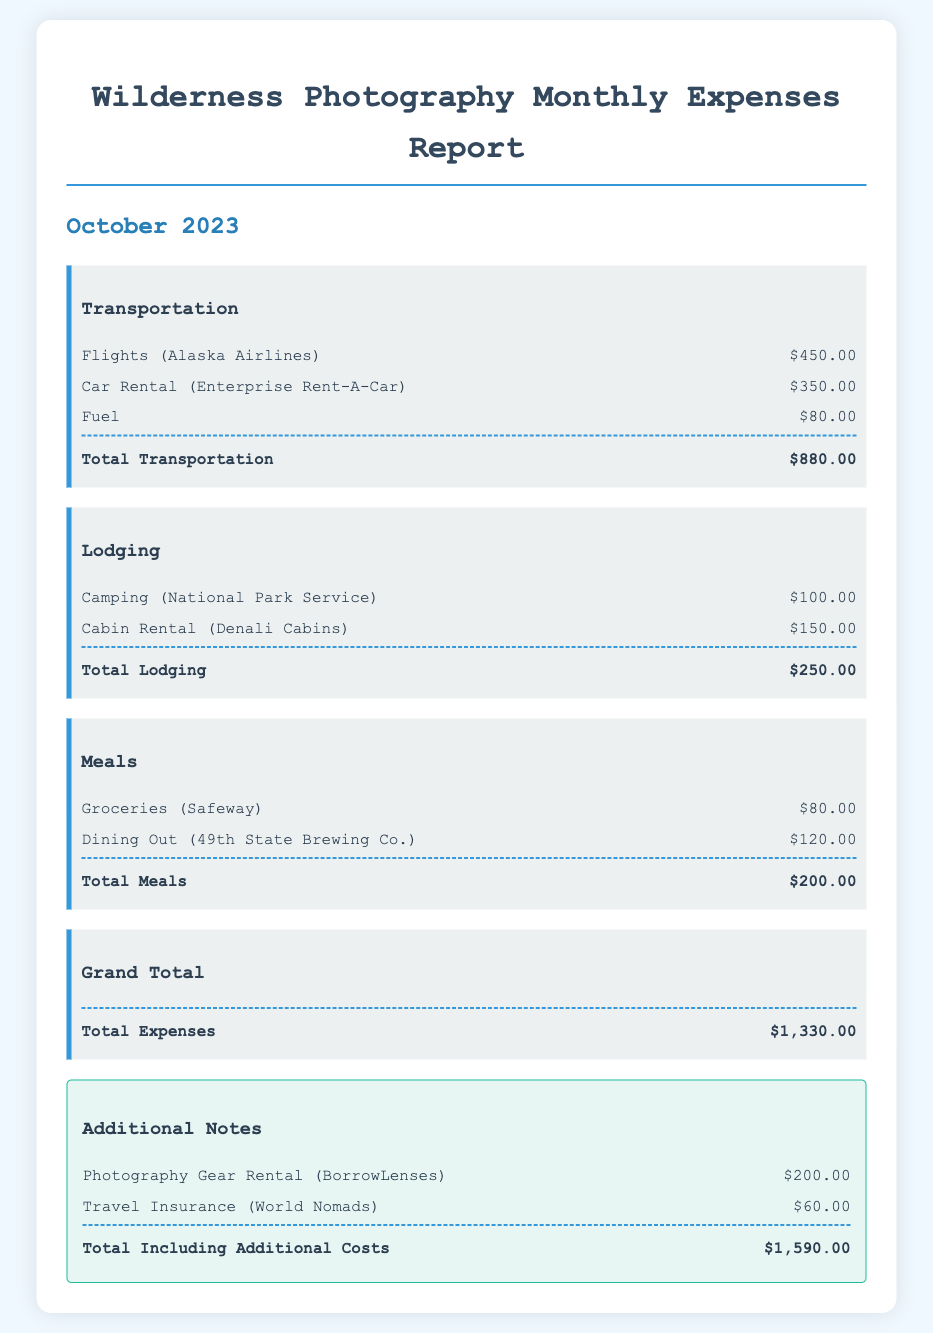What is the total transportation cost? The total for transportation is provided in the document as the sum of flights, car rental, and fuel costs, which is $450.00 + $350.00 + $80.00.
Answer: $880.00 How much was spent on lodging? The total lodging expense is the total of camping and cabin rental, which is $100.00 + $150.00.
Answer: $250.00 What was the cost of dining out? The document specifies that dining out at 49th State Brewing Co. occurred for $120.00.
Answer: $120.00 What is the grand total of expenses? The grand total is the overall sum of all expenses calculated in the report, which amounts to $1,330.00.
Answer: $1,330.00 How much was the photography gear rental? The photography gear rental cost is listed in the additional notes section as $200.00.
Answer: $200.00 What was the cost for travel insurance? The travel insurance cost from World Nomads is provided as $60.00 in the notes.
Answer: $60.00 What is the total including additional costs? The total including additional costs combines all expenses mentioned in the report, leading to $1,590.00.
Answer: $1,590.00 How many main categories of expenses are listed? The document outlines three main categories of expenses: Transportation, Lodging, and Meals.
Answer: Three What airline was used for flights? The flights were booked with Alaska Airlines as mentioned in the transportation section.
Answer: Alaska Airlines 